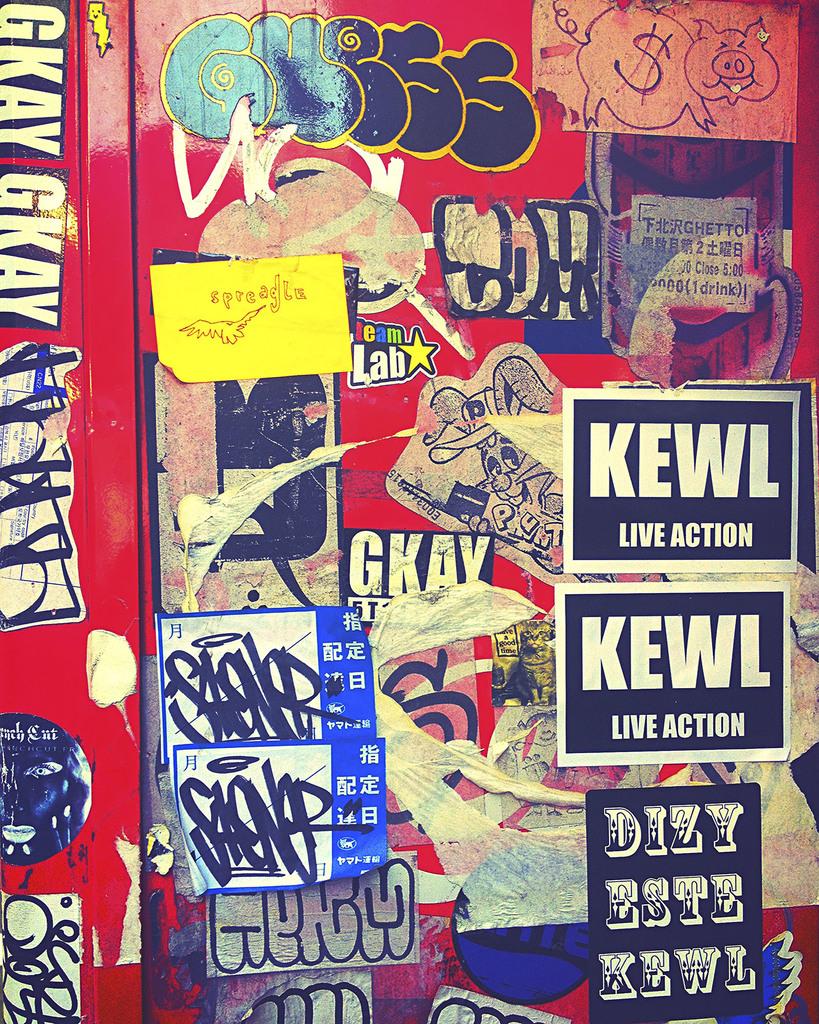What is "live?"?
Give a very brief answer. Action. What is the first letter on the yellow sign?
Keep it short and to the point. S. 